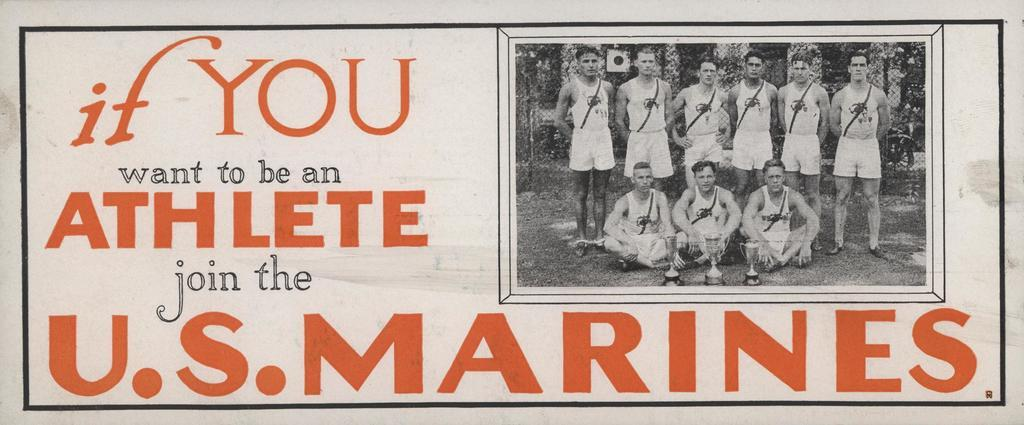<image>
Summarize the visual content of the image. Old propagand  featuring a team of athletes calling for people wanting to be athletes to join the U.S. Marines 